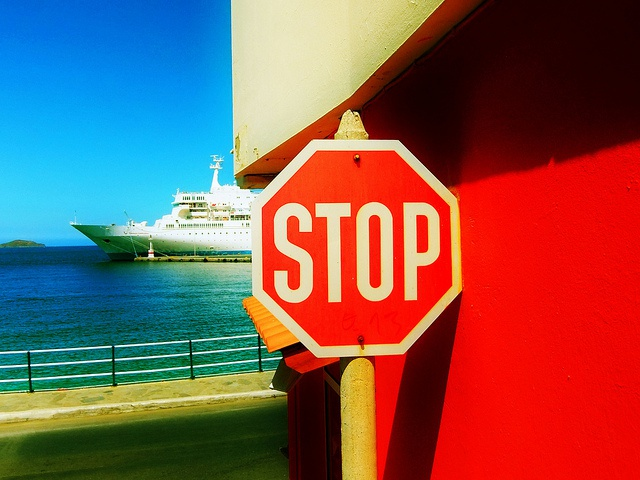Describe the objects in this image and their specific colors. I can see stop sign in blue, red, khaki, and beige tones and boat in blue, white, darkgreen, black, and olive tones in this image. 